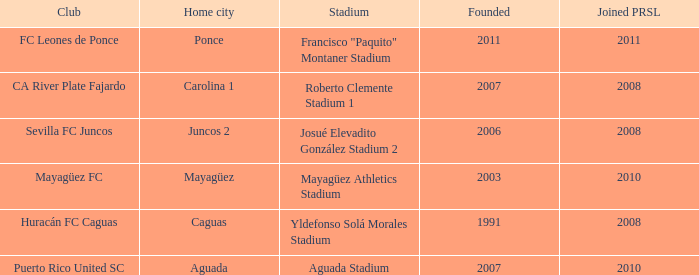What is the club that was founded before 2007, joined prsl in 2008 and the stadium is yldefonso solá morales stadium? Huracán FC Caguas. 